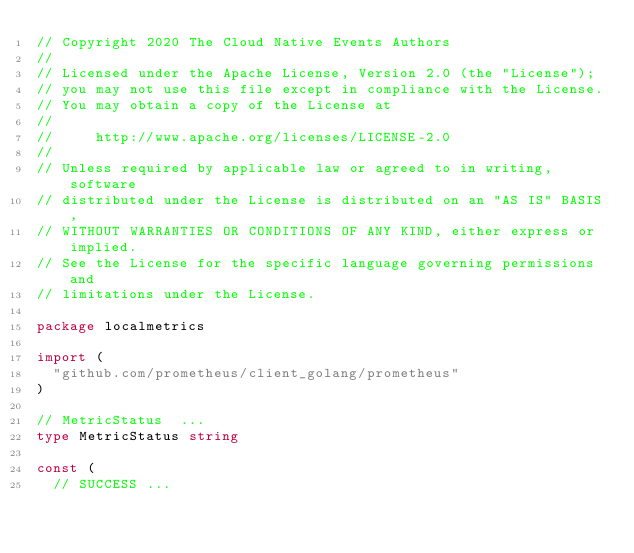Convert code to text. <code><loc_0><loc_0><loc_500><loc_500><_Go_>// Copyright 2020 The Cloud Native Events Authors
//
// Licensed under the Apache License, Version 2.0 (the "License");
// you may not use this file except in compliance with the License.
// You may obtain a copy of the License at
//
//     http://www.apache.org/licenses/LICENSE-2.0
//
// Unless required by applicable law or agreed to in writing, software
// distributed under the License is distributed on an "AS IS" BASIS,
// WITHOUT WARRANTIES OR CONDITIONS OF ANY KIND, either express or implied.
// See the License for the specific language governing permissions and
// limitations under the License.

package localmetrics

import (
	"github.com/prometheus/client_golang/prometheus"
)

// MetricStatus  ...
type MetricStatus string

const (
	// SUCCESS ...</code> 